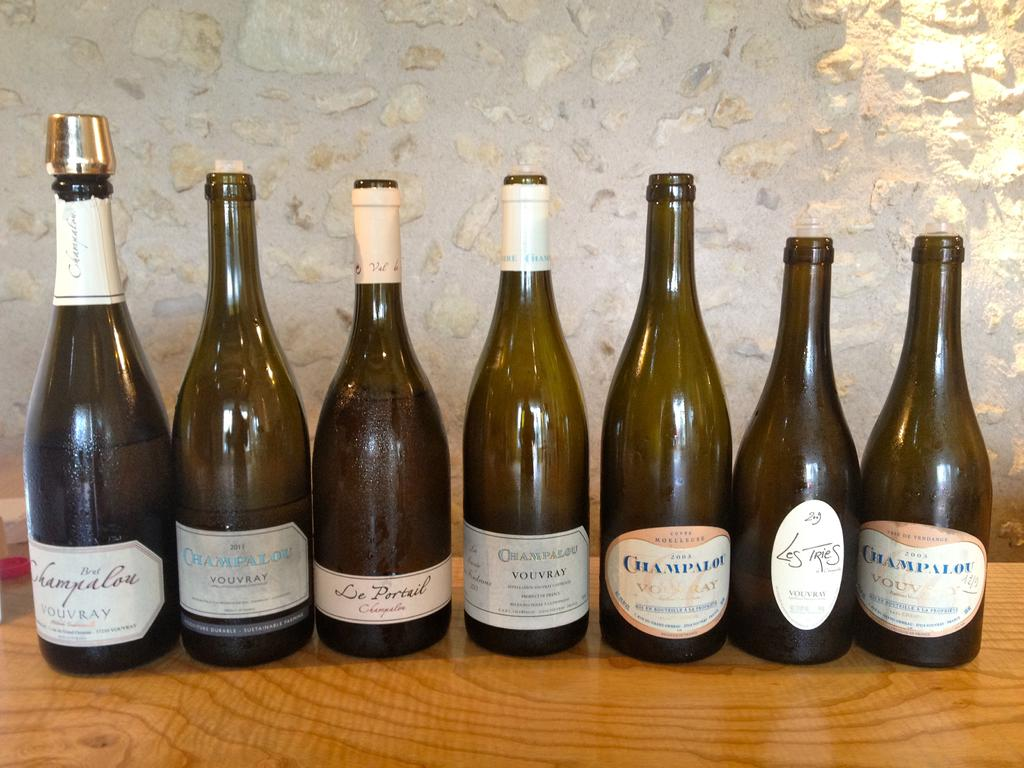What objects are on the table in the image? There is a group of bottles on the table in the image. What can be seen in the background of the image? There is a white color wall in the background of the image. How does the ship navigate through the bottles in the image? There is no ship present in the image; it only features a group of bottles on the table. 